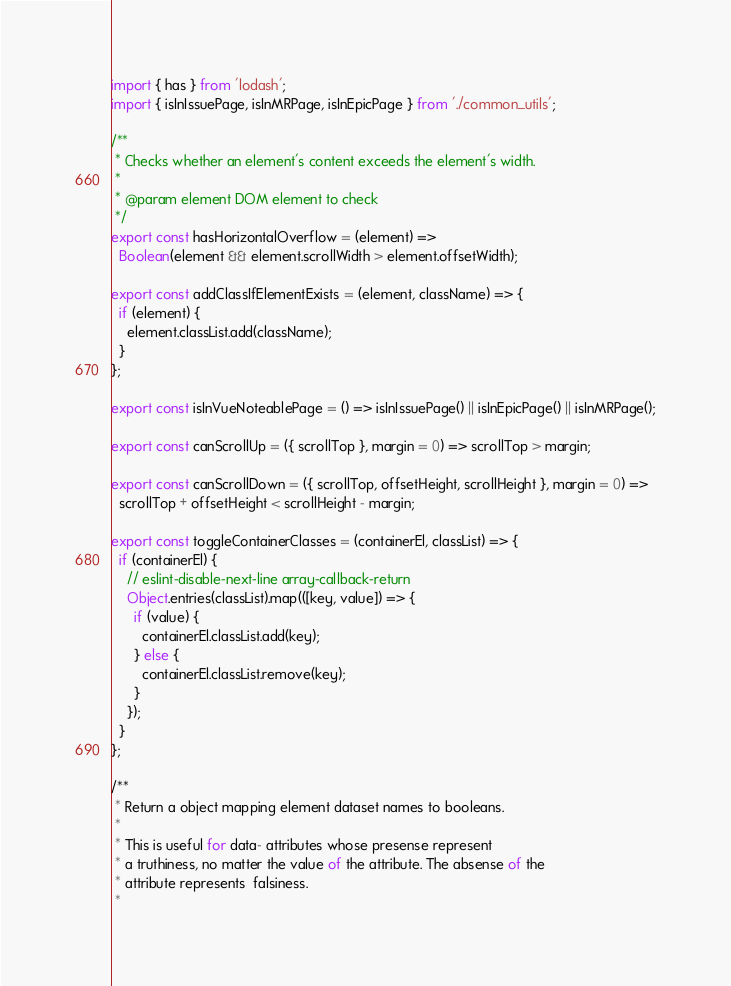Convert code to text. <code><loc_0><loc_0><loc_500><loc_500><_JavaScript_>import { has } from 'lodash';
import { isInIssuePage, isInMRPage, isInEpicPage } from './common_utils';

/**
 * Checks whether an element's content exceeds the element's width.
 *
 * @param element DOM element to check
 */
export const hasHorizontalOverflow = (element) =>
  Boolean(element && element.scrollWidth > element.offsetWidth);

export const addClassIfElementExists = (element, className) => {
  if (element) {
    element.classList.add(className);
  }
};

export const isInVueNoteablePage = () => isInIssuePage() || isInEpicPage() || isInMRPage();

export const canScrollUp = ({ scrollTop }, margin = 0) => scrollTop > margin;

export const canScrollDown = ({ scrollTop, offsetHeight, scrollHeight }, margin = 0) =>
  scrollTop + offsetHeight < scrollHeight - margin;

export const toggleContainerClasses = (containerEl, classList) => {
  if (containerEl) {
    // eslint-disable-next-line array-callback-return
    Object.entries(classList).map(([key, value]) => {
      if (value) {
        containerEl.classList.add(key);
      } else {
        containerEl.classList.remove(key);
      }
    });
  }
};

/**
 * Return a object mapping element dataset names to booleans.
 *
 * This is useful for data- attributes whose presense represent
 * a truthiness, no matter the value of the attribute. The absense of the
 * attribute represents  falsiness.
 *</code> 